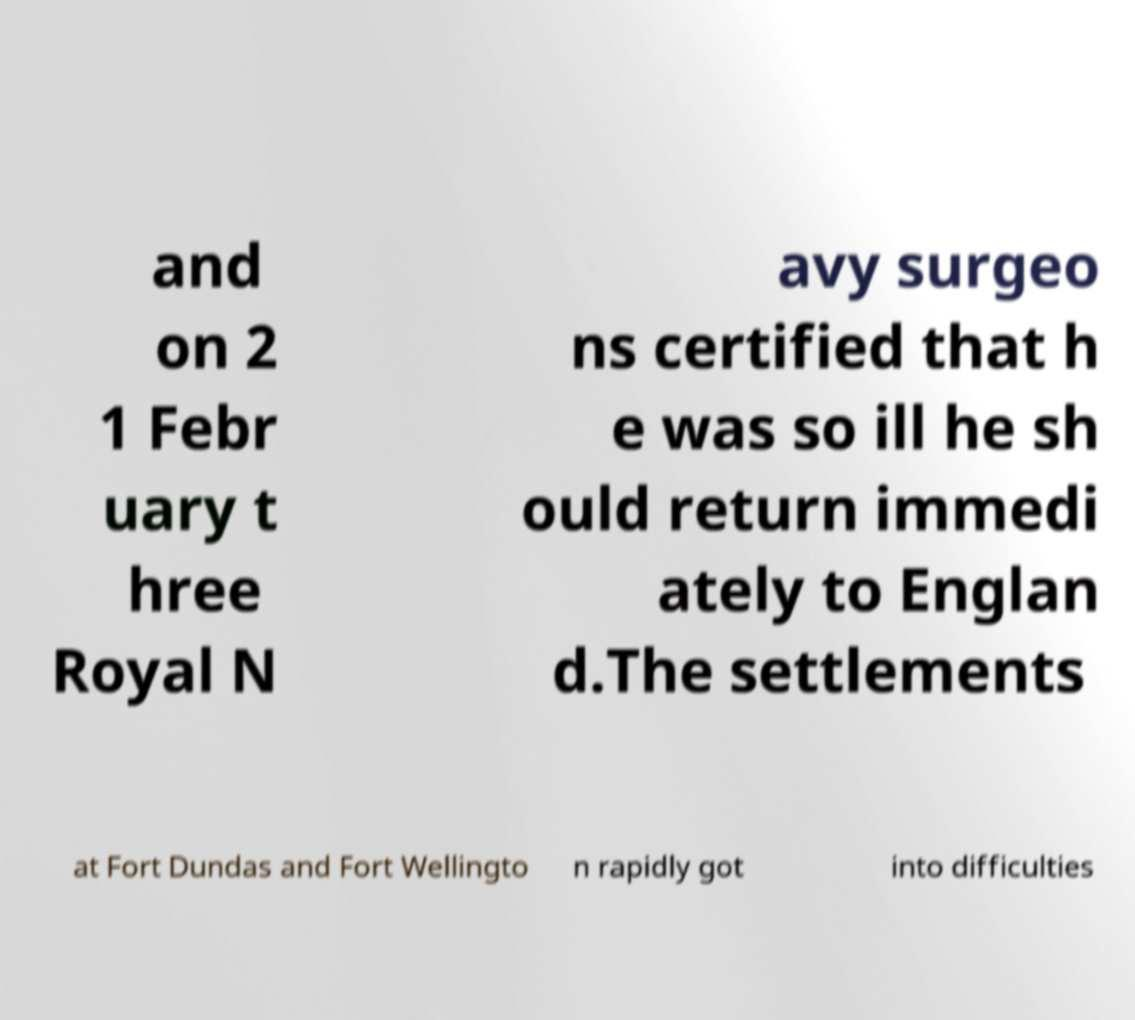Please read and relay the text visible in this image. What does it say? and on 2 1 Febr uary t hree Royal N avy surgeo ns certified that h e was so ill he sh ould return immedi ately to Englan d.The settlements at Fort Dundas and Fort Wellingto n rapidly got into difficulties 